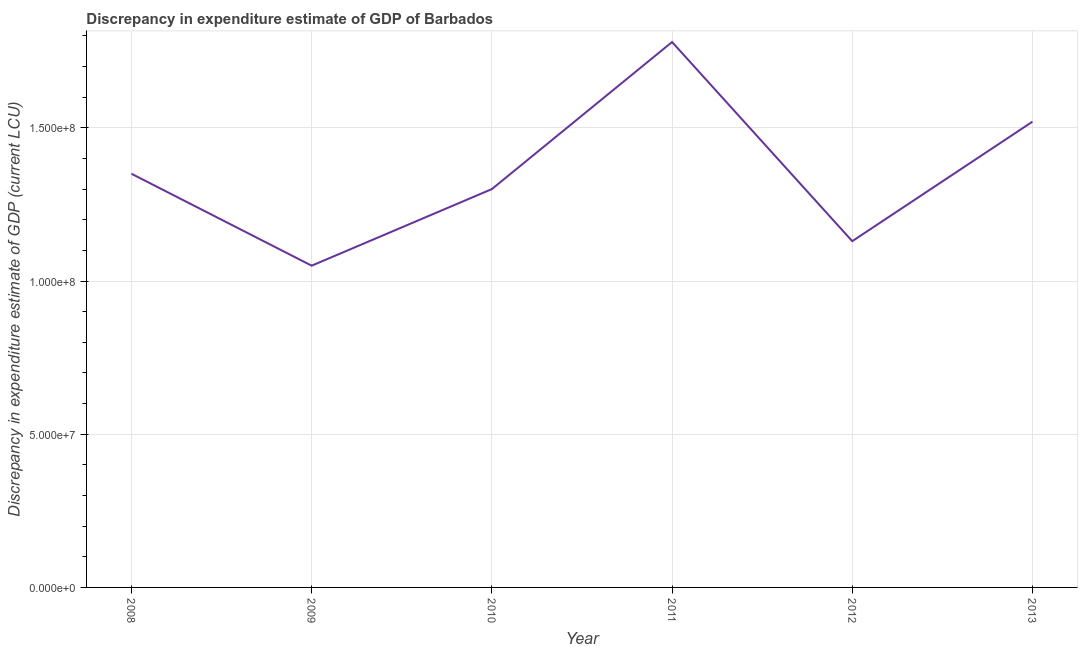What is the discrepancy in expenditure estimate of gdp in 2009?
Your answer should be compact. 1.05e+08. Across all years, what is the maximum discrepancy in expenditure estimate of gdp?
Offer a very short reply. 1.78e+08. Across all years, what is the minimum discrepancy in expenditure estimate of gdp?
Keep it short and to the point. 1.05e+08. In which year was the discrepancy in expenditure estimate of gdp maximum?
Provide a short and direct response. 2011. In which year was the discrepancy in expenditure estimate of gdp minimum?
Your answer should be compact. 2009. What is the sum of the discrepancy in expenditure estimate of gdp?
Offer a terse response. 8.13e+08. What is the difference between the discrepancy in expenditure estimate of gdp in 2009 and 2012?
Offer a very short reply. -8.00e+06. What is the average discrepancy in expenditure estimate of gdp per year?
Provide a short and direct response. 1.36e+08. What is the median discrepancy in expenditure estimate of gdp?
Provide a short and direct response. 1.32e+08. Do a majority of the years between 2009 and 2011 (inclusive) have discrepancy in expenditure estimate of gdp greater than 20000000 LCU?
Make the answer very short. Yes. What is the ratio of the discrepancy in expenditure estimate of gdp in 2009 to that in 2012?
Offer a very short reply. 0.93. Is the discrepancy in expenditure estimate of gdp in 2009 less than that in 2013?
Keep it short and to the point. Yes. What is the difference between the highest and the second highest discrepancy in expenditure estimate of gdp?
Your response must be concise. 2.60e+07. Is the sum of the discrepancy in expenditure estimate of gdp in 2008 and 2009 greater than the maximum discrepancy in expenditure estimate of gdp across all years?
Offer a very short reply. Yes. What is the difference between the highest and the lowest discrepancy in expenditure estimate of gdp?
Make the answer very short. 7.30e+07. In how many years, is the discrepancy in expenditure estimate of gdp greater than the average discrepancy in expenditure estimate of gdp taken over all years?
Your answer should be very brief. 2. How many lines are there?
Ensure brevity in your answer.  1. How many years are there in the graph?
Keep it short and to the point. 6. What is the difference between two consecutive major ticks on the Y-axis?
Your answer should be compact. 5.00e+07. Does the graph contain any zero values?
Offer a terse response. No. What is the title of the graph?
Your response must be concise. Discrepancy in expenditure estimate of GDP of Barbados. What is the label or title of the X-axis?
Provide a short and direct response. Year. What is the label or title of the Y-axis?
Provide a short and direct response. Discrepancy in expenditure estimate of GDP (current LCU). What is the Discrepancy in expenditure estimate of GDP (current LCU) of 2008?
Make the answer very short. 1.35e+08. What is the Discrepancy in expenditure estimate of GDP (current LCU) of 2009?
Offer a very short reply. 1.05e+08. What is the Discrepancy in expenditure estimate of GDP (current LCU) in 2010?
Keep it short and to the point. 1.30e+08. What is the Discrepancy in expenditure estimate of GDP (current LCU) in 2011?
Give a very brief answer. 1.78e+08. What is the Discrepancy in expenditure estimate of GDP (current LCU) in 2012?
Your answer should be very brief. 1.13e+08. What is the Discrepancy in expenditure estimate of GDP (current LCU) of 2013?
Your answer should be very brief. 1.52e+08. What is the difference between the Discrepancy in expenditure estimate of GDP (current LCU) in 2008 and 2009?
Make the answer very short. 3.00e+07. What is the difference between the Discrepancy in expenditure estimate of GDP (current LCU) in 2008 and 2010?
Give a very brief answer. 5.00e+06. What is the difference between the Discrepancy in expenditure estimate of GDP (current LCU) in 2008 and 2011?
Offer a terse response. -4.30e+07. What is the difference between the Discrepancy in expenditure estimate of GDP (current LCU) in 2008 and 2012?
Your response must be concise. 2.20e+07. What is the difference between the Discrepancy in expenditure estimate of GDP (current LCU) in 2008 and 2013?
Ensure brevity in your answer.  -1.70e+07. What is the difference between the Discrepancy in expenditure estimate of GDP (current LCU) in 2009 and 2010?
Ensure brevity in your answer.  -2.50e+07. What is the difference between the Discrepancy in expenditure estimate of GDP (current LCU) in 2009 and 2011?
Ensure brevity in your answer.  -7.30e+07. What is the difference between the Discrepancy in expenditure estimate of GDP (current LCU) in 2009 and 2012?
Provide a short and direct response. -8.00e+06. What is the difference between the Discrepancy in expenditure estimate of GDP (current LCU) in 2009 and 2013?
Provide a short and direct response. -4.70e+07. What is the difference between the Discrepancy in expenditure estimate of GDP (current LCU) in 2010 and 2011?
Offer a very short reply. -4.80e+07. What is the difference between the Discrepancy in expenditure estimate of GDP (current LCU) in 2010 and 2012?
Provide a succinct answer. 1.70e+07. What is the difference between the Discrepancy in expenditure estimate of GDP (current LCU) in 2010 and 2013?
Offer a very short reply. -2.20e+07. What is the difference between the Discrepancy in expenditure estimate of GDP (current LCU) in 2011 and 2012?
Make the answer very short. 6.50e+07. What is the difference between the Discrepancy in expenditure estimate of GDP (current LCU) in 2011 and 2013?
Your answer should be compact. 2.60e+07. What is the difference between the Discrepancy in expenditure estimate of GDP (current LCU) in 2012 and 2013?
Your response must be concise. -3.90e+07. What is the ratio of the Discrepancy in expenditure estimate of GDP (current LCU) in 2008 to that in 2009?
Your answer should be very brief. 1.29. What is the ratio of the Discrepancy in expenditure estimate of GDP (current LCU) in 2008 to that in 2010?
Offer a terse response. 1.04. What is the ratio of the Discrepancy in expenditure estimate of GDP (current LCU) in 2008 to that in 2011?
Offer a very short reply. 0.76. What is the ratio of the Discrepancy in expenditure estimate of GDP (current LCU) in 2008 to that in 2012?
Make the answer very short. 1.2. What is the ratio of the Discrepancy in expenditure estimate of GDP (current LCU) in 2008 to that in 2013?
Provide a short and direct response. 0.89. What is the ratio of the Discrepancy in expenditure estimate of GDP (current LCU) in 2009 to that in 2010?
Ensure brevity in your answer.  0.81. What is the ratio of the Discrepancy in expenditure estimate of GDP (current LCU) in 2009 to that in 2011?
Your answer should be very brief. 0.59. What is the ratio of the Discrepancy in expenditure estimate of GDP (current LCU) in 2009 to that in 2012?
Your response must be concise. 0.93. What is the ratio of the Discrepancy in expenditure estimate of GDP (current LCU) in 2009 to that in 2013?
Your answer should be very brief. 0.69. What is the ratio of the Discrepancy in expenditure estimate of GDP (current LCU) in 2010 to that in 2011?
Your answer should be compact. 0.73. What is the ratio of the Discrepancy in expenditure estimate of GDP (current LCU) in 2010 to that in 2012?
Offer a very short reply. 1.15. What is the ratio of the Discrepancy in expenditure estimate of GDP (current LCU) in 2010 to that in 2013?
Your answer should be very brief. 0.85. What is the ratio of the Discrepancy in expenditure estimate of GDP (current LCU) in 2011 to that in 2012?
Your answer should be compact. 1.57. What is the ratio of the Discrepancy in expenditure estimate of GDP (current LCU) in 2011 to that in 2013?
Offer a terse response. 1.17. What is the ratio of the Discrepancy in expenditure estimate of GDP (current LCU) in 2012 to that in 2013?
Offer a very short reply. 0.74. 